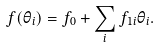Convert formula to latex. <formula><loc_0><loc_0><loc_500><loc_500>f ( \theta _ { i } ) = f _ { 0 } + \sum _ { i } f _ { 1 i } \theta _ { i } .</formula> 